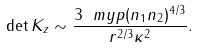<formula> <loc_0><loc_0><loc_500><loc_500>\det K _ { z } \sim \frac { 3 \ m y p ( n _ { 1 } n _ { 2 } ) ^ { 4 / 3 } } { r ^ { 2 / 3 } \kappa ^ { 2 } } .</formula> 